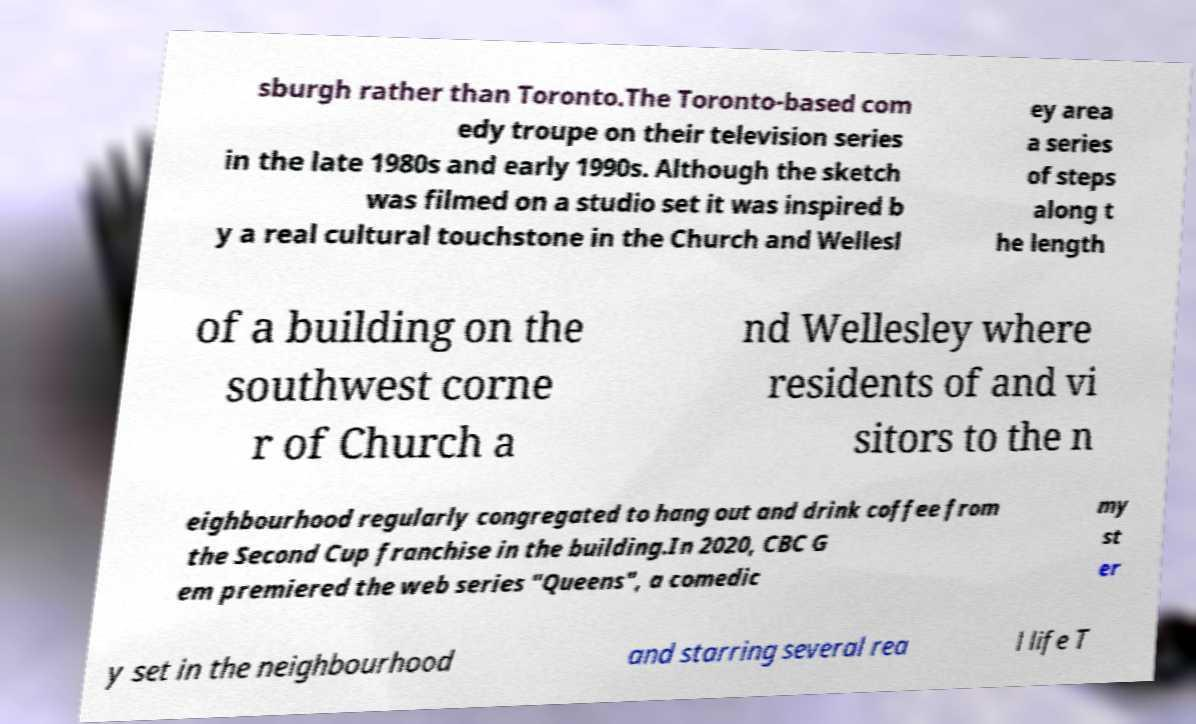For documentation purposes, I need the text within this image transcribed. Could you provide that? sburgh rather than Toronto.The Toronto-based com edy troupe on their television series in the late 1980s and early 1990s. Although the sketch was filmed on a studio set it was inspired b y a real cultural touchstone in the Church and Wellesl ey area a series of steps along t he length of a building on the southwest corne r of Church a nd Wellesley where residents of and vi sitors to the n eighbourhood regularly congregated to hang out and drink coffee from the Second Cup franchise in the building.In 2020, CBC G em premiered the web series "Queens", a comedic my st er y set in the neighbourhood and starring several rea l life T 